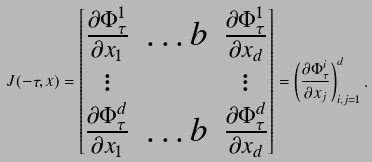<formula> <loc_0><loc_0><loc_500><loc_500>J ( - \tau , x ) = \begin{bmatrix} \frac { \partial \Phi ^ { 1 } _ { \tau } } { \partial x _ { 1 } } & \dots b & \frac { \partial \Phi ^ { 1 } _ { \tau } } { \partial x _ { d } } \\ \vdots & & \vdots \\ \frac { \partial \Phi ^ { d } _ { \tau } } { \partial x _ { 1 } } & \dots b & \frac { \partial \Phi ^ { d } _ { \tau } } { \partial x _ { d } } \end{bmatrix} = \left ( \frac { \partial \Phi ^ { i } _ { \tau } } { \partial x _ { j } } \right ) _ { i , j = 1 } ^ { d } .</formula> 